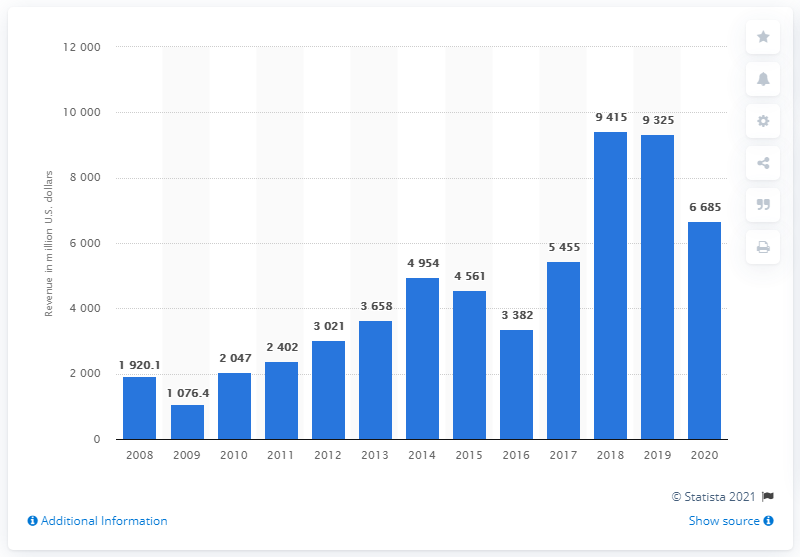Indicate a few pertinent items in this graphic. In 2020, Pioneer Natural Resources generated approximately $66,850,000 in revenue. 